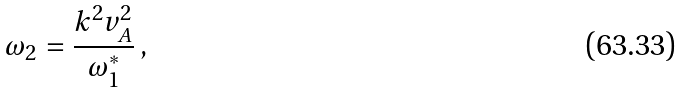Convert formula to latex. <formula><loc_0><loc_0><loc_500><loc_500>\omega _ { 2 } = \frac { k ^ { 2 } v _ { A } ^ { 2 } } { \omega _ { 1 } ^ { * } } \, ,</formula> 